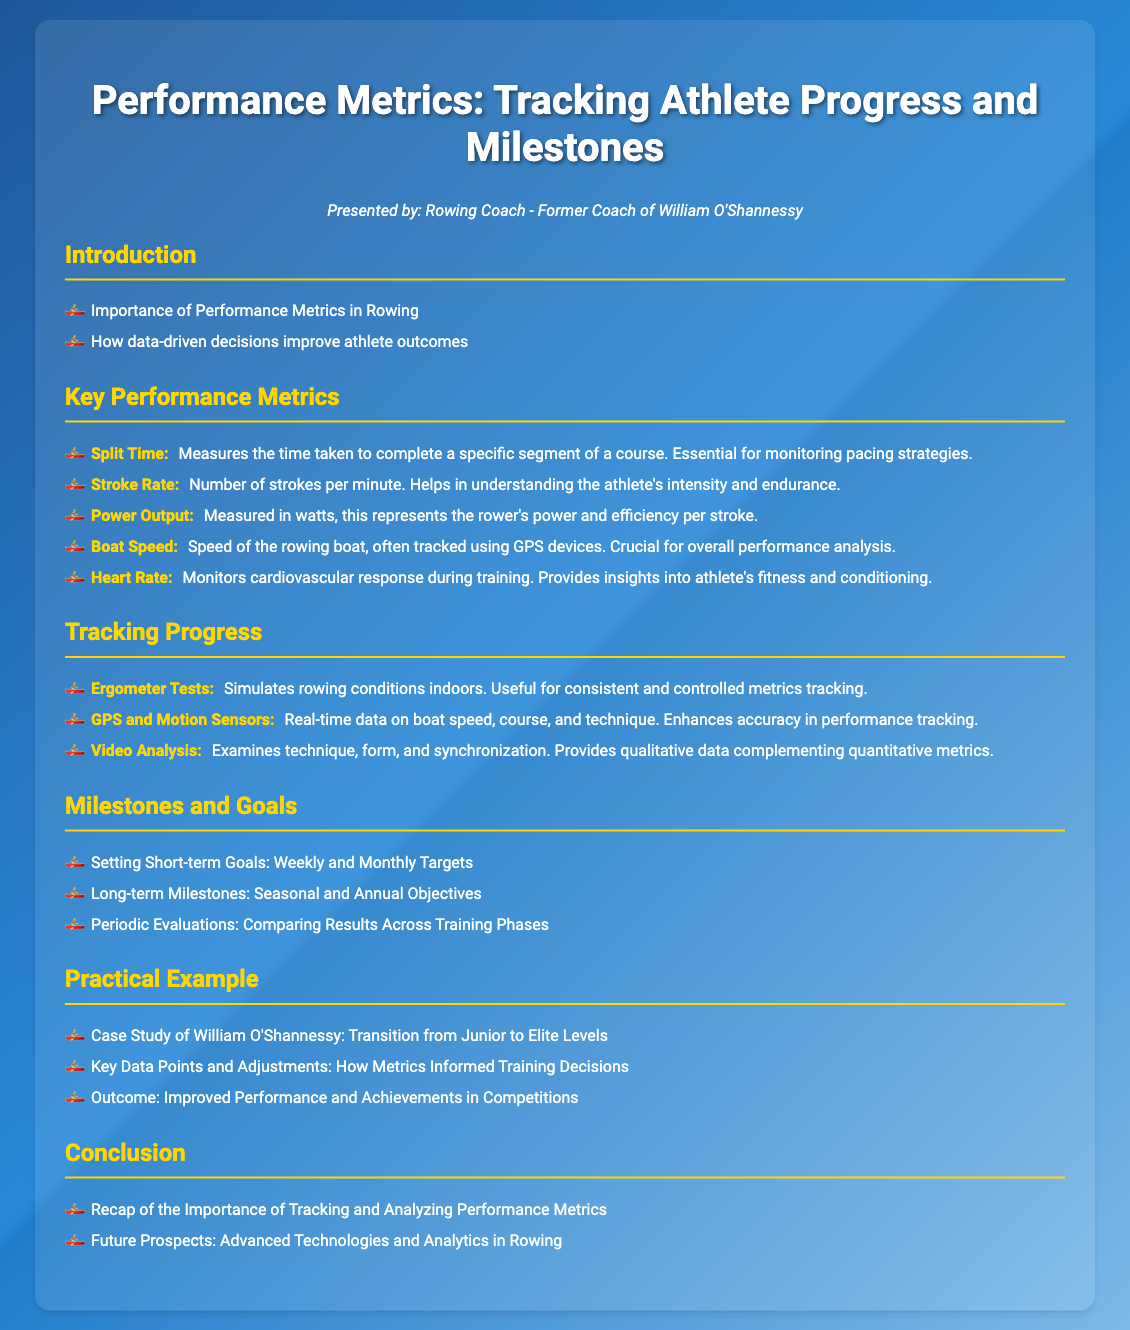what is the title of the presentation? The title of the presentation is displayed prominently at the top of the slide.
Answer: Performance Metrics: Tracking Athlete Progress and Milestones who presented this document? The document provides the name of the presenter, indicated below the title.
Answer: Rowing Coach - Former Coach of William O'Shannessy what metric measures the number of strokes per minute? This metric is specifically mentioned in the list of key performance metrics in the document.
Answer: Stroke Rate which tool simulates rowing conditions indoors? This tool is listed under the section for tracking progress.
Answer: Ergometer Tests what is the outcome of the case study on William O'Shannessy? The document describes the result of the case study in the Practical Example section.
Answer: Improved Performance and Achievements in Competitions what are the goals set for tracking athlete progress? The presentation outlines different types of goals under the Milestones and Goals section.
Answer: Short-term Goals: Weekly and Monthly Targets, Long-term Milestones: Seasonal and Annual Objectives, Periodic Evaluations what technology provides real-time data on boat speed? This technology is listed as a tool for tracking progress in the document.
Answer: GPS and Motion Sensors what is the purpose of video analysis mentioned in the document? The description for this tool indicates its function in analyzing athlete's performance.
Answer: Examines technique, form, and synchronization 